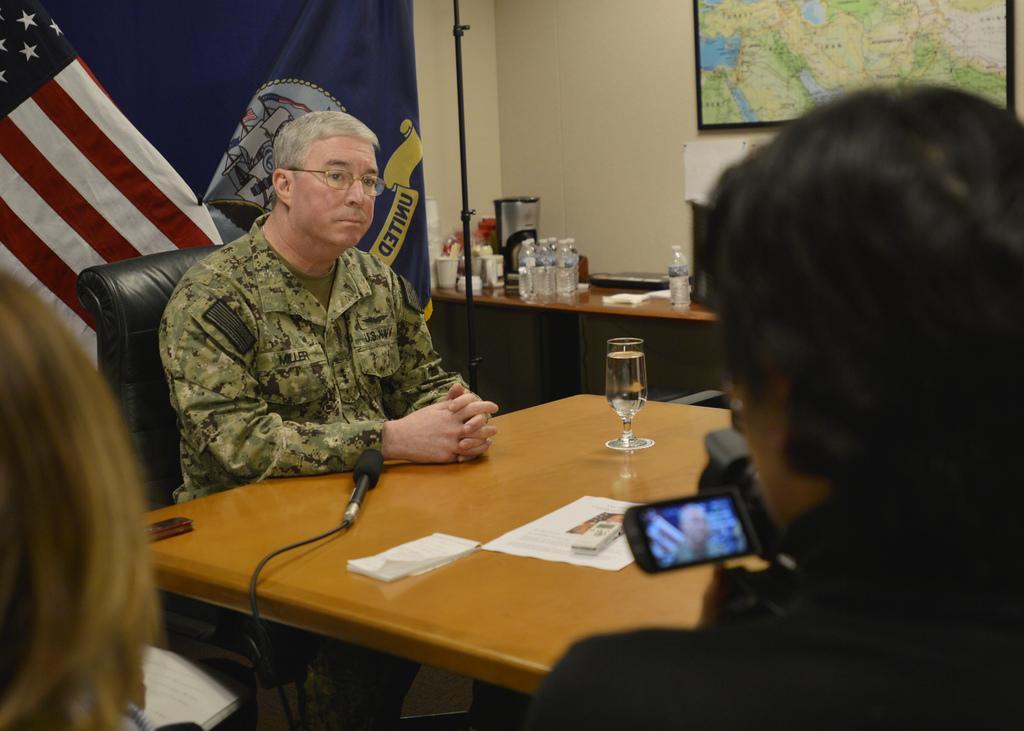Can you describe this image briefly? This man is sitting on a chair. In-front of this man there is a table, on this table there is a book, paper, glass of water and mic. Backside of this man there are flags. Map is on the wall. On that table there are bottles, cup and things. Front this man is holding a camera. 